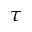Convert formula to latex. <formula><loc_0><loc_0><loc_500><loc_500>\tau</formula> 